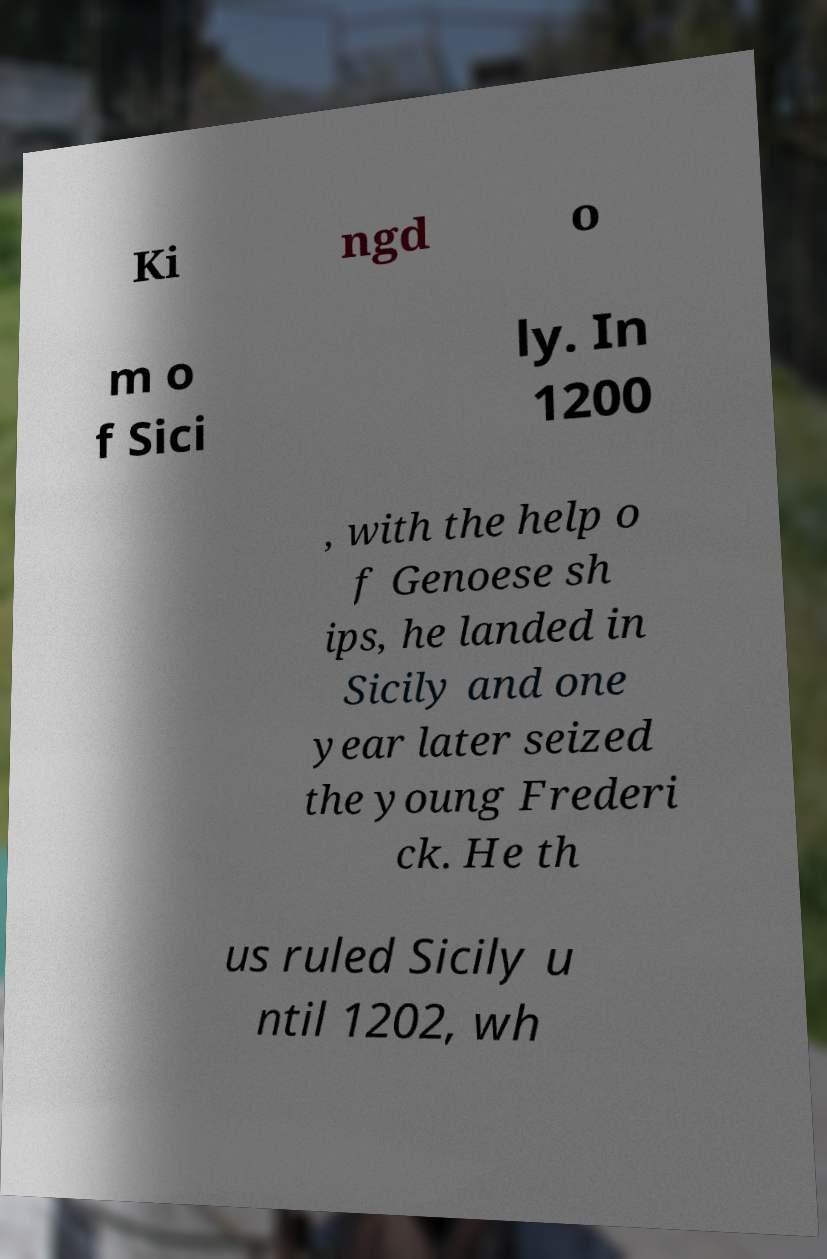I need the written content from this picture converted into text. Can you do that? Ki ngd o m o f Sici ly. In 1200 , with the help o f Genoese sh ips, he landed in Sicily and one year later seized the young Frederi ck. He th us ruled Sicily u ntil 1202, wh 